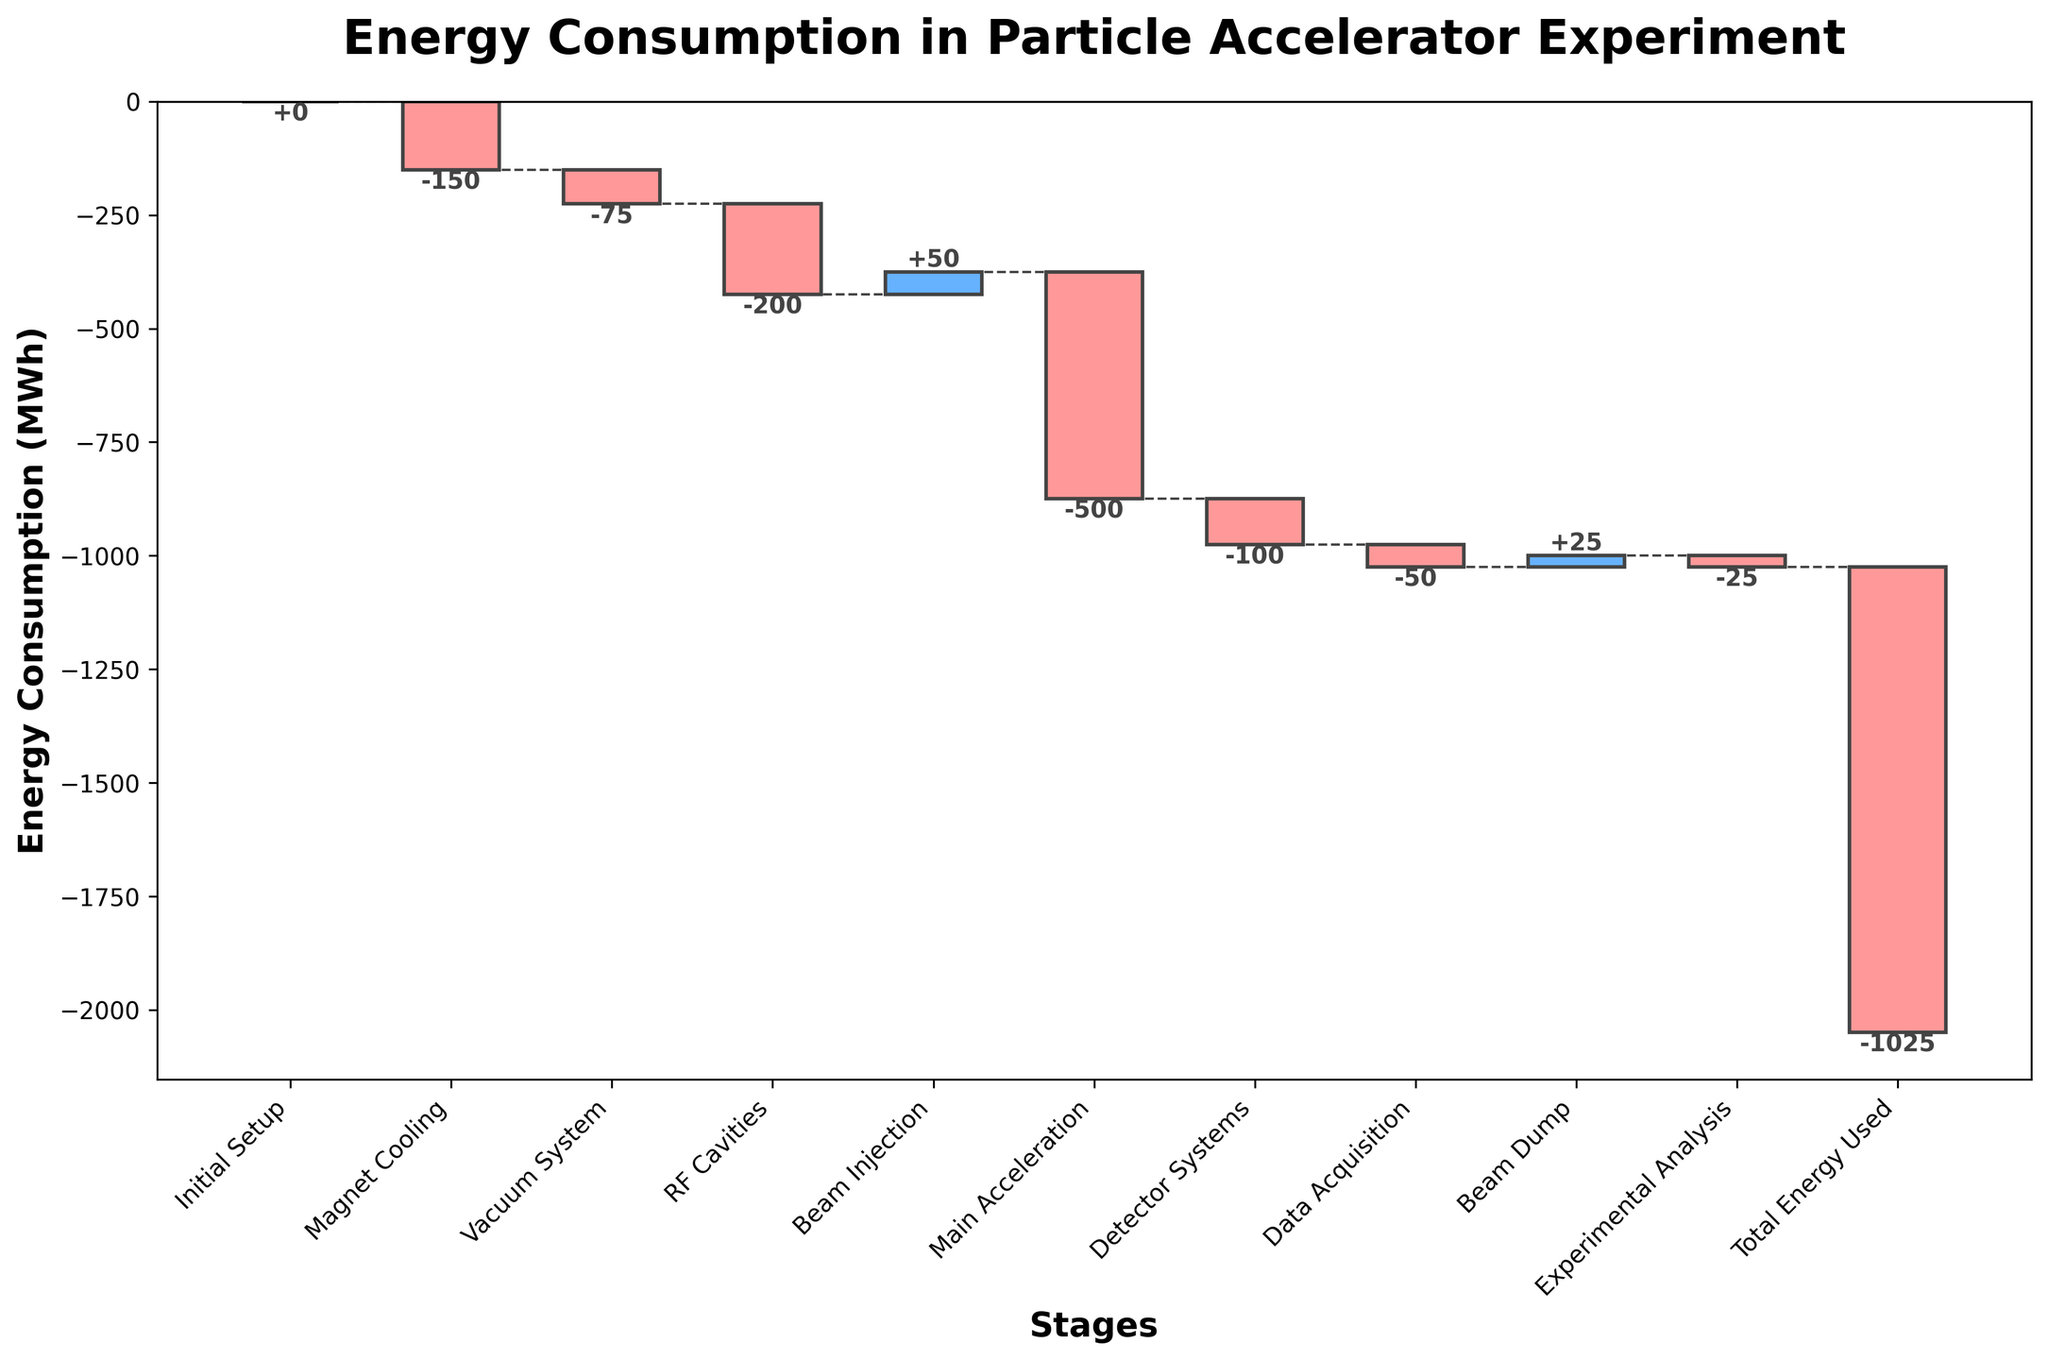How many stages are shown in the chart? The chart has bars for each stage indicated on the x-axis. By counting these bars, we see there are 11 stages.
Answer: 11 What is the total energy consumption of the vacuum system? The vacuum system's energy consumption is represented by a single bar labeled "Vacuum System," which indicates -75 MWh.
Answer: -75 MWh Which stage has the largest negative energy consumption, and what is the value? By looking for the longest red bar below the zero line, we can see that "Main Acceleration" has the largest negative consumption with -500 MWh.
Answer: Main Acceleration, -500 MWh How does the energy consumption of the RF Cavities compare to that of the Beam Injection? The RF Cavities use -200 MWh, which is compared to the +50 MWh used by Beam Injection. Therefore, the RF Cavities consume 250 MWh more energy than is generated by Beam Injection.
Answer: RF Cavities use 250 MWh more What is the cumulative energy consumption after the detector systems stage? After Detector Systems, cumulative energy is found by adding up the initial setup, magnet cooling, vacuum system, RF cavities, beam injection, main acceleration, and detector systems: 0 - 150 - 75 - 200 + 50 - 500 - 100 = -975 MWh.
Answer: -975 MWh How does the energy consumption of the beam dump stage influence the total energy used? The Beam Dump contributes +25 MWh, which reduces the overall negative energy consumption since it's a positive value.
Answer: Reduces total energy used by +25 MWh What is the change in cumulative energy consumption from initial setup to main acceleration? The initial setup starts at 0 and after main acceleration, it totals: 0 - 150 - 75 - 200 + 50 - 500 = -875 MWh.
Answer: -875 MWh At which stage does the cumulative energy consumption cross the -500 MWh mark? Adding up the stages until the cumulative energy consumption crosses -500 MWh: 0 - 150 - 75 - 200 + 50 = -375; after Main Acceleration additional -500 goes cumulative to -875 MWh; hence crosses after "Main Acceleration".
Answer: Main Acceleration Is the energy consumption of the beam dump larger or smaller than that of the experimental analysis? The beam dump has an energy consumption of +25 MWh and experimental analysis has -25 MWh, making beam dump larger.
Answer: Beam Dump is larger What is the final cumulative energy consumption at the end of the experimental analysis? Adding all stages: 0 - 150 - 75 - 200 + 50 - 500 - 100 - 50 + 25 - 25 = -1025 MWh.
Answer: -1025 MWh 